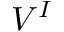<formula> <loc_0><loc_0><loc_500><loc_500>V ^ { I }</formula> 